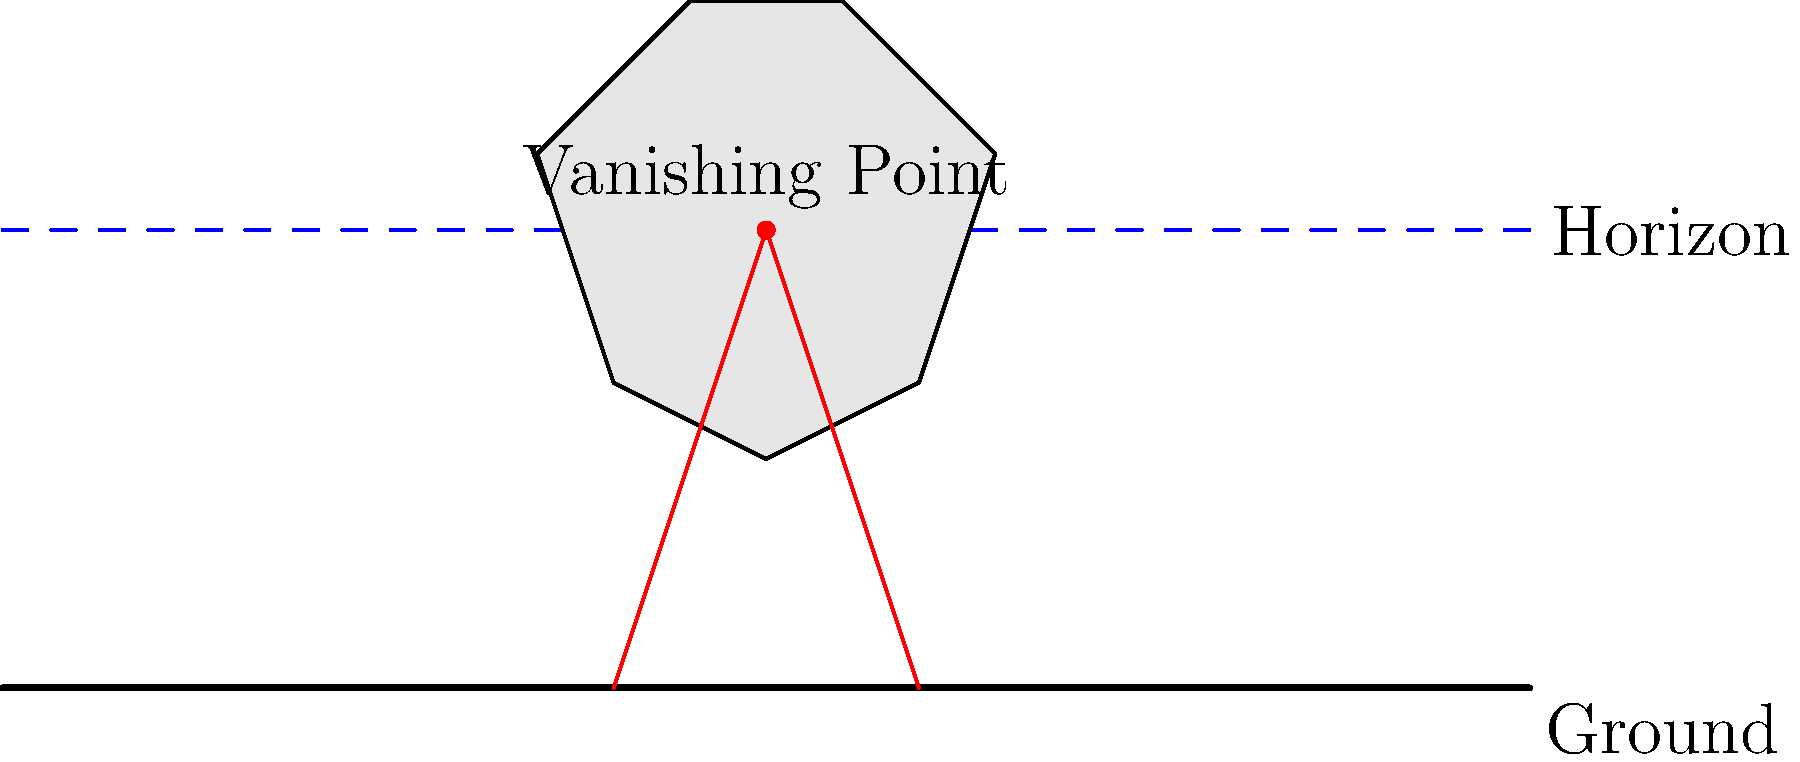In the illustration of a floating magical castle, what perspective technique is being demonstrated, and how does it contribute to creating depth in the image? To answer this question, let's analyze the key elements of the illustration:

1. Horizon line: The blue dashed line represents the eye level of the viewer.

2. Vanishing point: The red dot on the horizon line is the vanishing point, where parallel lines converge in the distance.

3. Perspective lines: The red lines extending from the ground to the vanishing point demonstrate how objects appear smaller as they recede into the distance.

4. Castle placement: The castle is positioned above the horizon line, creating the illusion of a floating structure.

The perspective technique being demonstrated is one-point linear perspective. This technique is characterized by:

a) A single vanishing point on the horizon line
b) Parallel lines converging at the vanishing point
c) Objects appearing smaller as they approach the vanishing point

One-point perspective contributes to creating depth in the image by:

1. Establishing a clear foreground, middle ground, and background
2. Creating a sense of distance between the viewer and the castle
3. Providing a consistent and realistic representation of space

For fantasy illustration, this technique is particularly useful in creating believable otherworldly scenes, as it grounds fantastical elements (like a floating castle) in a recognizable spatial framework.
Answer: One-point linear perspective 